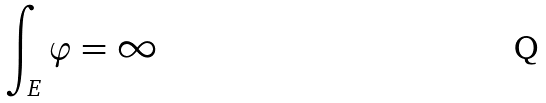<formula> <loc_0><loc_0><loc_500><loc_500>\int _ { E } \varphi = \infty</formula> 